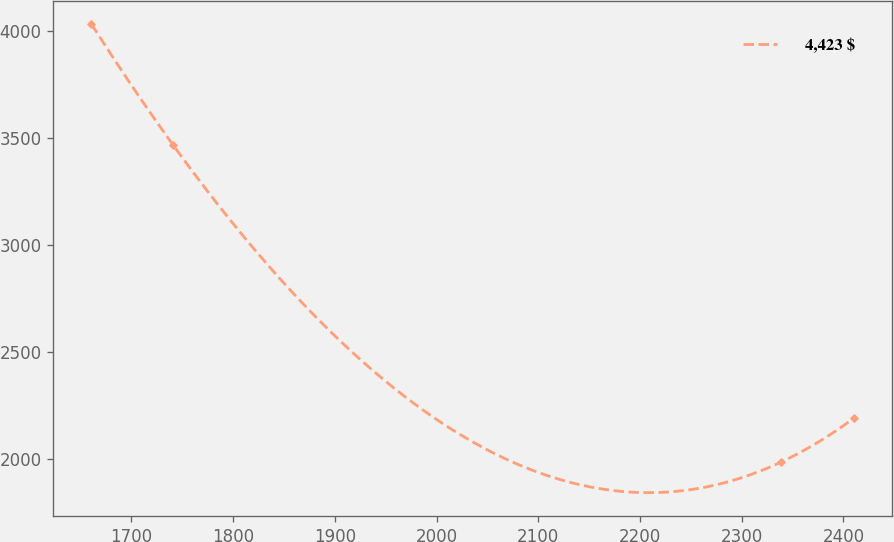Convert chart. <chart><loc_0><loc_0><loc_500><loc_500><line_chart><ecel><fcel>4,423 $<nl><fcel>1660.77<fcel>4032.93<nl><fcel>1741.25<fcel>3466.6<nl><fcel>2338.46<fcel>1986.83<nl><fcel>2409.95<fcel>2191.44<nl></chart> 